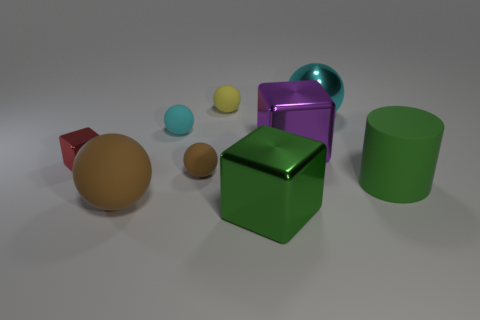Do the red metal object and the big shiny thing in front of the large brown rubber object have the same shape?
Offer a terse response. Yes. What is the shape of the big green thing that is to the left of the green thing that is on the right side of the big block behind the red block?
Provide a succinct answer. Cube. How many other objects are there of the same material as the small brown sphere?
Give a very brief answer. 4. How many things are tiny rubber balls that are behind the large purple thing or tiny cyan rubber cylinders?
Your answer should be compact. 2. There is a large matte object behind the big ball that is left of the purple metal cube; what is its shape?
Your response must be concise. Cylinder. There is a cyan thing in front of the large cyan sphere; is its shape the same as the small yellow matte object?
Your response must be concise. Yes. What color is the metallic object behind the cyan matte ball?
Keep it short and to the point. Cyan. How many blocks are either small blue shiny objects or small yellow objects?
Ensure brevity in your answer.  0. There is a metallic cube that is in front of the green thing that is to the right of the large green metallic cube; what is its size?
Offer a very short reply. Large. There is a big rubber sphere; is its color the same as the small ball that is in front of the large purple metal thing?
Keep it short and to the point. Yes. 